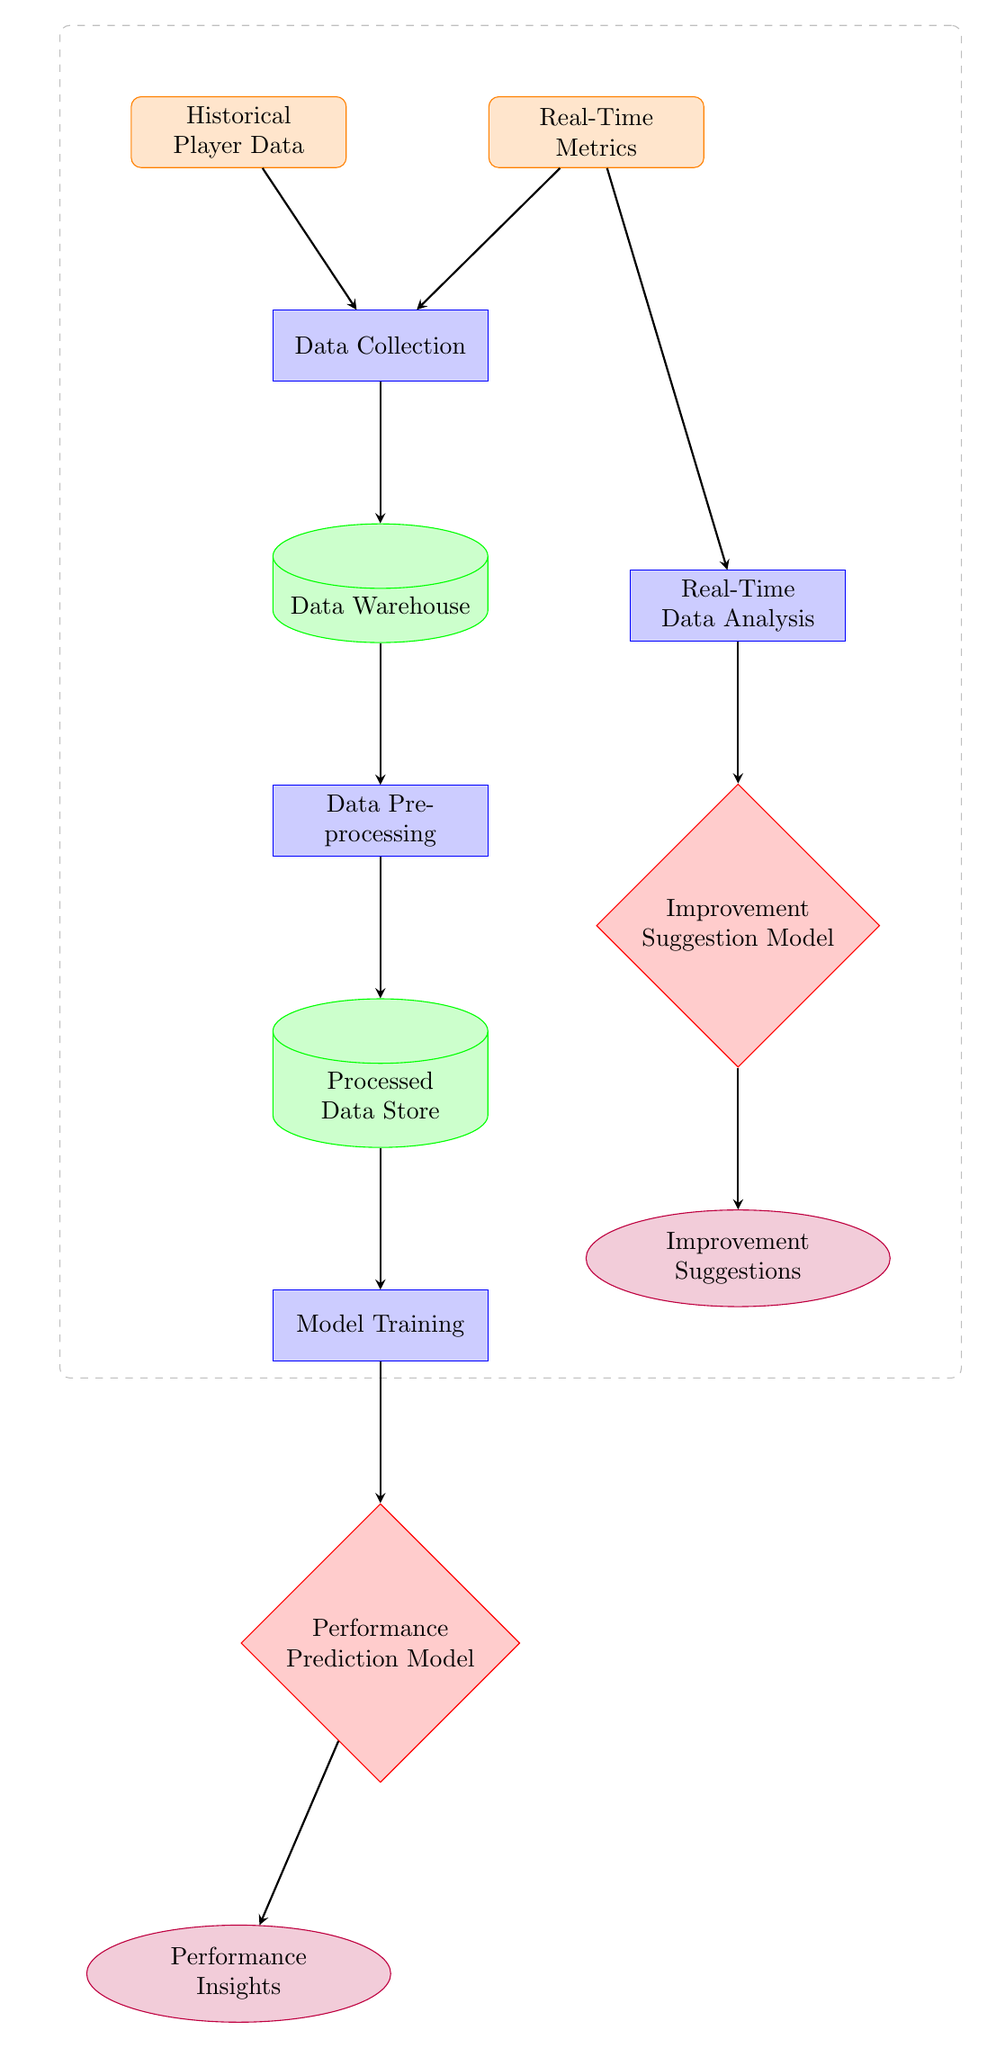How many data nodes are in the diagram? The diagram includes two data nodes: "Historical Player Data" and "Real-Time Metrics."
Answer: 2 What is the output of the "Performance Prediction Model"? The output of the "Performance Prediction Model" is "Performance Insights," as shown in the diagram.
Answer: Performance Insights What process follows "Model Training"? After "Model Training," the next process is "Performance Prediction Model," which is directly indicated by the arrow in the diagram.
Answer: Performance Prediction Model What type of model is the "Improvement Suggestion Model"? The "Improvement Suggestion Model" is represented by a diamond shape in the diagram, indicating it functions as a model.
Answer: Model Which process analyzes real-time data? The "Real-Time Data Analysis" process is responsible for analyzing real-time data, as indicated in the diagram.
Answer: Real-Time Data Analysis What two types of data are collected? The two types of data collected are "Historical Player Data" and "Real-Time Metrics," as shown on the right and left of the data collection node.
Answer: Historical Player Data and Real-Time Metrics What is the final output of the diagram? The final output is "Improvement Suggestions," which is produced after the "Improvement Suggestion Model."
Answer: Improvement Suggestions Which node directly provides inputs to the "Data Collection" process? The nodes that provide inputs to the "Data Collection" process are "Historical Player Data" and "Real-Time Metrics," both pointing to it.
Answer: Historical Player Data and Real-Time Metrics What is the purpose of the "Data Warehouse" node? The "Data Warehouse" node serves as a storage unit for the collected data, which is a common function within data processing flows.
Answer: Data Warehouse 